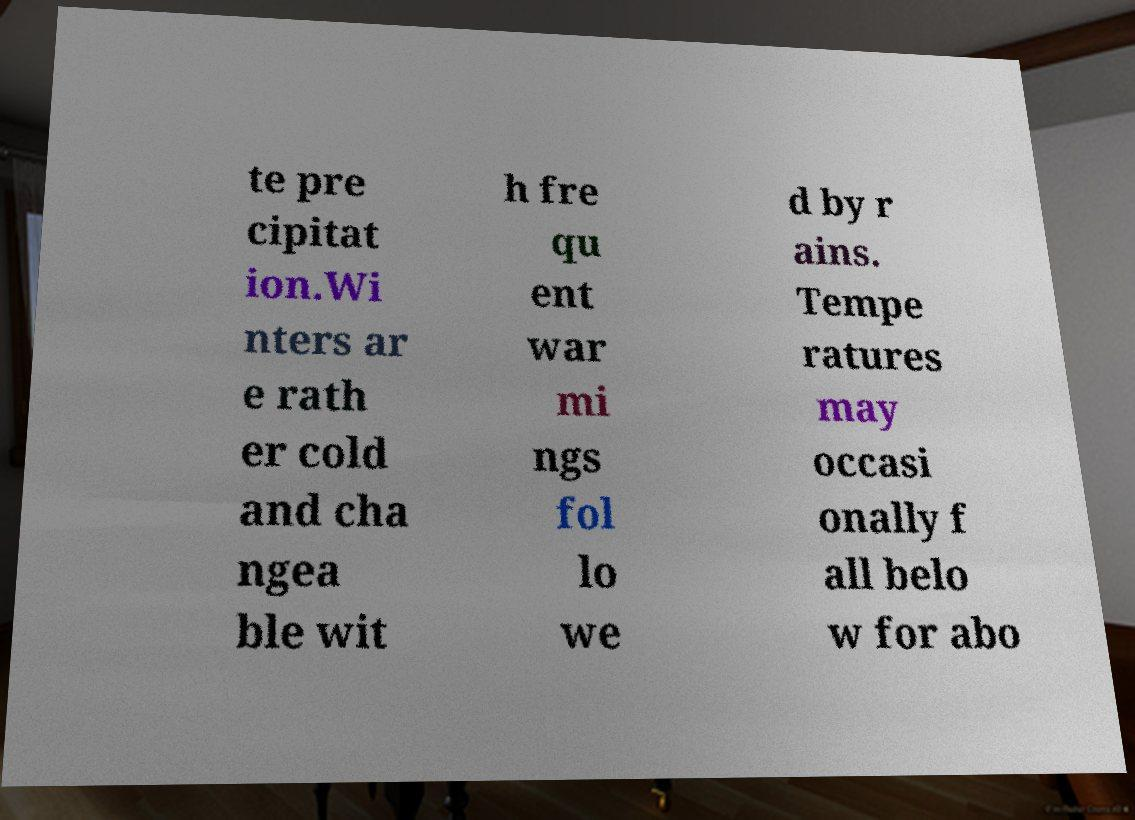I need the written content from this picture converted into text. Can you do that? te pre cipitat ion.Wi nters ar e rath er cold and cha ngea ble wit h fre qu ent war mi ngs fol lo we d by r ains. Tempe ratures may occasi onally f all belo w for abo 